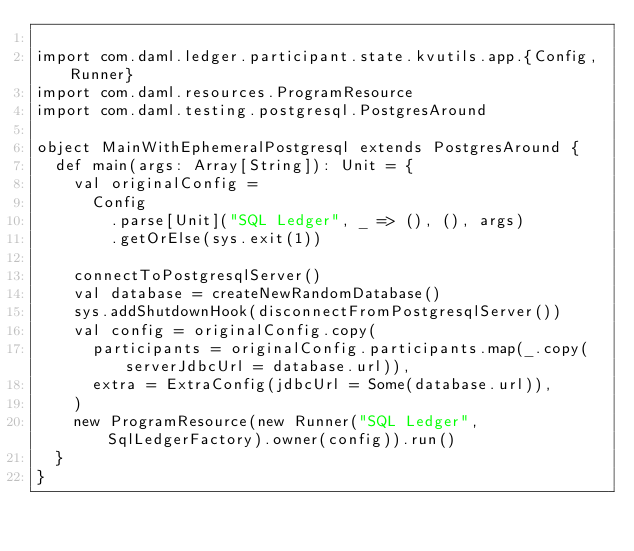<code> <loc_0><loc_0><loc_500><loc_500><_Scala_>
import com.daml.ledger.participant.state.kvutils.app.{Config, Runner}
import com.daml.resources.ProgramResource
import com.daml.testing.postgresql.PostgresAround

object MainWithEphemeralPostgresql extends PostgresAround {
  def main(args: Array[String]): Unit = {
    val originalConfig =
      Config
        .parse[Unit]("SQL Ledger", _ => (), (), args)
        .getOrElse(sys.exit(1))

    connectToPostgresqlServer()
    val database = createNewRandomDatabase()
    sys.addShutdownHook(disconnectFromPostgresqlServer())
    val config = originalConfig.copy(
      participants = originalConfig.participants.map(_.copy(serverJdbcUrl = database.url)),
      extra = ExtraConfig(jdbcUrl = Some(database.url)),
    )
    new ProgramResource(new Runner("SQL Ledger", SqlLedgerFactory).owner(config)).run()
  }
}
</code> 